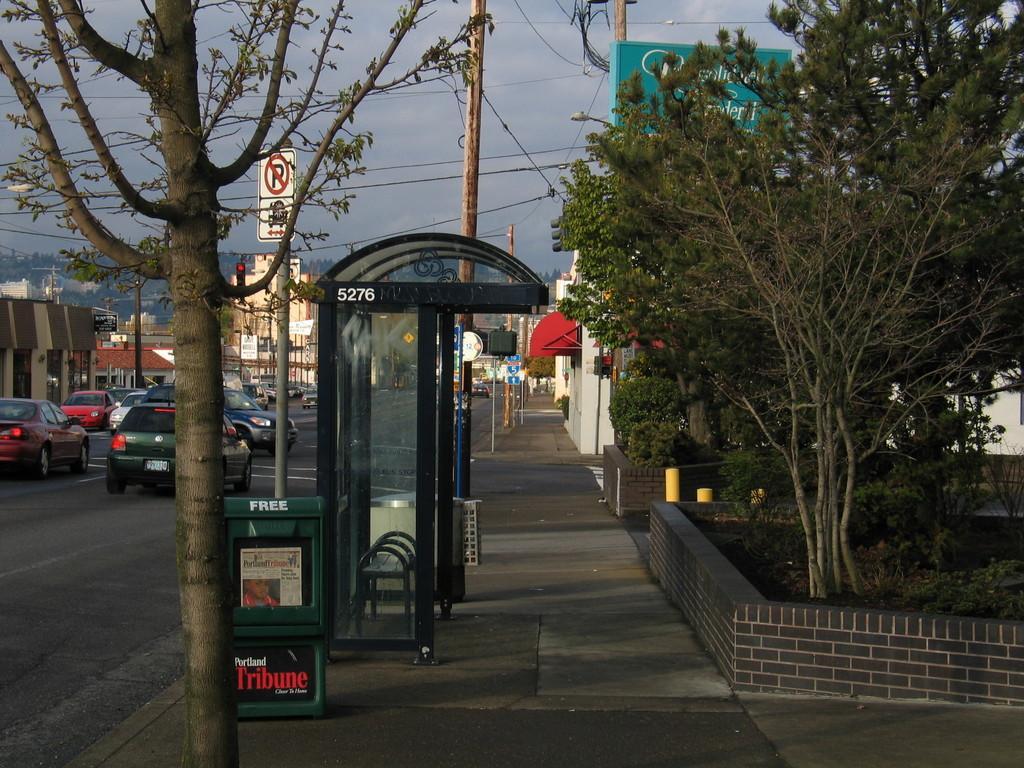Describe this image in one or two sentences. In the picture we can see a pathway on it we can see a tree, bus shelter, and a pole and beside it we can see some plants around it we can see wall and beside it we can see some house buildings and on the road we can see some cars and in the background we can see some trees and sky. 